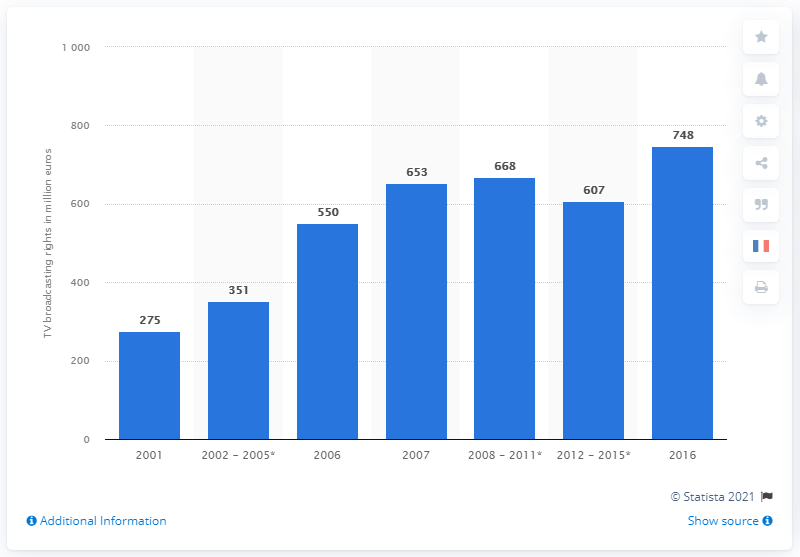Point out several critical features in this image. The revenue generated from the television broadcasting rights for Ligue 1 in 2016 was 748 million. 